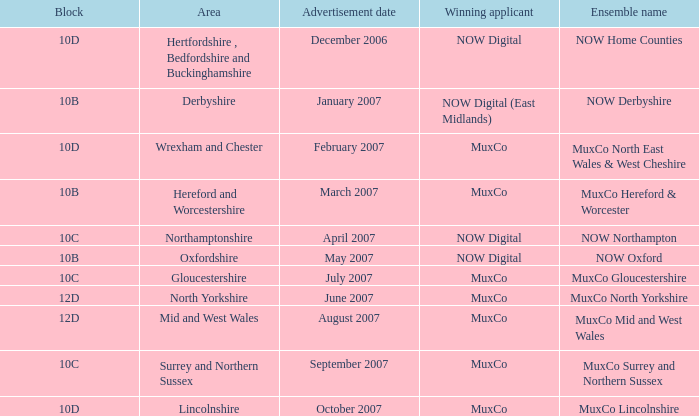Who is the Winning Applicant of Ensemble Name Muxco Lincolnshire in Block 10D? MuxCo. 